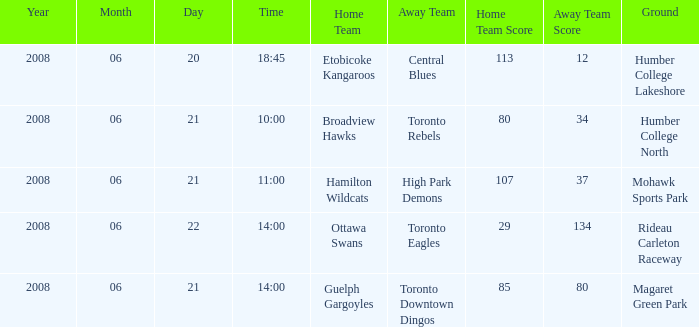What is the Ground with a Date that is 2008-06-20? Humber College Lakeshore. 